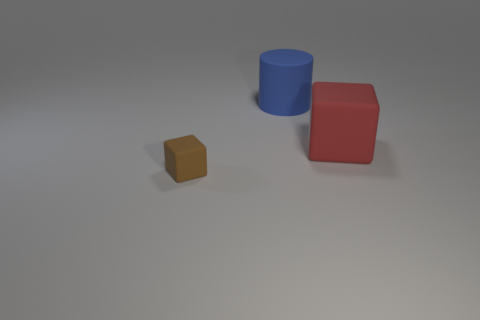Which object in the image is the tallest? The tallest object in the image is the blue cylinder, standing taller than both the red cube and the tiny brown block. 